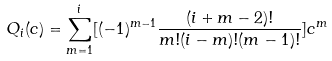<formula> <loc_0><loc_0><loc_500><loc_500>Q _ { i } ( c ) = \sum _ { m = 1 } ^ { i } [ ( - 1 ) ^ { m - 1 } \frac { ( i + m - 2 ) ! } { m ! ( i - m ) ! ( m - 1 ) ! } ] c ^ { m }</formula> 